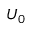Convert formula to latex. <formula><loc_0><loc_0><loc_500><loc_500>U _ { 0 }</formula> 